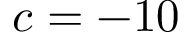Convert formula to latex. <formula><loc_0><loc_0><loc_500><loc_500>c = - 1 0</formula> 